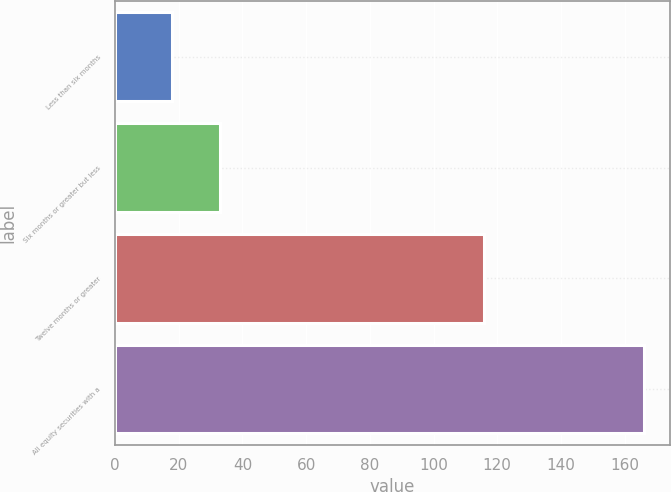Convert chart to OTSL. <chart><loc_0><loc_0><loc_500><loc_500><bar_chart><fcel>Less than six months<fcel>Six months or greater but less<fcel>Twelve months or greater<fcel>All equity securities with a<nl><fcel>18<fcel>32.8<fcel>116<fcel>166<nl></chart> 